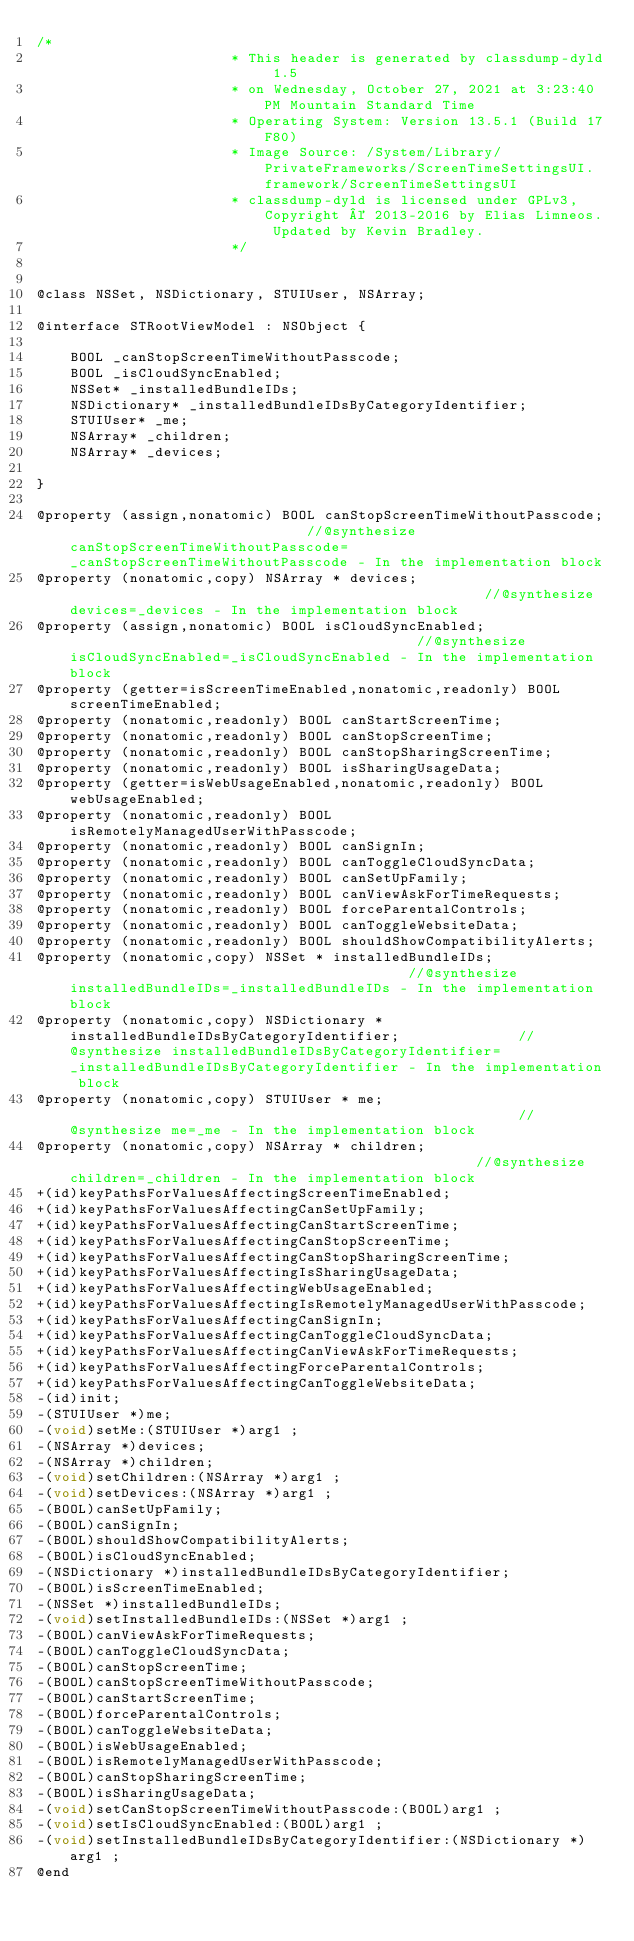<code> <loc_0><loc_0><loc_500><loc_500><_C_>/*
                       * This header is generated by classdump-dyld 1.5
                       * on Wednesday, October 27, 2021 at 3:23:40 PM Mountain Standard Time
                       * Operating System: Version 13.5.1 (Build 17F80)
                       * Image Source: /System/Library/PrivateFrameworks/ScreenTimeSettingsUI.framework/ScreenTimeSettingsUI
                       * classdump-dyld is licensed under GPLv3, Copyright © 2013-2016 by Elias Limneos. Updated by Kevin Bradley.
                       */


@class NSSet, NSDictionary, STUIUser, NSArray;

@interface STRootViewModel : NSObject {

	BOOL _canStopScreenTimeWithoutPasscode;
	BOOL _isCloudSyncEnabled;
	NSSet* _installedBundleIDs;
	NSDictionary* _installedBundleIDsByCategoryIdentifier;
	STUIUser* _me;
	NSArray* _children;
	NSArray* _devices;

}

@property (assign,nonatomic) BOOL canStopScreenTimeWithoutPasscode;                            //@synthesize canStopScreenTimeWithoutPasscode=_canStopScreenTimeWithoutPasscode - In the implementation block
@property (nonatomic,copy) NSArray * devices;                                                  //@synthesize devices=_devices - In the implementation block
@property (assign,nonatomic) BOOL isCloudSyncEnabled;                                          //@synthesize isCloudSyncEnabled=_isCloudSyncEnabled - In the implementation block
@property (getter=isScreenTimeEnabled,nonatomic,readonly) BOOL screenTimeEnabled; 
@property (nonatomic,readonly) BOOL canStartScreenTime; 
@property (nonatomic,readonly) BOOL canStopScreenTime; 
@property (nonatomic,readonly) BOOL canStopSharingScreenTime; 
@property (nonatomic,readonly) BOOL isSharingUsageData; 
@property (getter=isWebUsageEnabled,nonatomic,readonly) BOOL webUsageEnabled; 
@property (nonatomic,readonly) BOOL isRemotelyManagedUserWithPasscode; 
@property (nonatomic,readonly) BOOL canSignIn; 
@property (nonatomic,readonly) BOOL canToggleCloudSyncData; 
@property (nonatomic,readonly) BOOL canSetUpFamily; 
@property (nonatomic,readonly) BOOL canViewAskForTimeRequests; 
@property (nonatomic,readonly) BOOL forceParentalControls; 
@property (nonatomic,readonly) BOOL canToggleWebsiteData; 
@property (nonatomic,readonly) BOOL shouldShowCompatibilityAlerts; 
@property (nonatomic,copy) NSSet * installedBundleIDs;                                         //@synthesize installedBundleIDs=_installedBundleIDs - In the implementation block
@property (nonatomic,copy) NSDictionary * installedBundleIDsByCategoryIdentifier;              //@synthesize installedBundleIDsByCategoryIdentifier=_installedBundleIDsByCategoryIdentifier - In the implementation block
@property (nonatomic,copy) STUIUser * me;                                                      //@synthesize me=_me - In the implementation block
@property (nonatomic,copy) NSArray * children;                                                 //@synthesize children=_children - In the implementation block
+(id)keyPathsForValuesAffectingScreenTimeEnabled;
+(id)keyPathsForValuesAffectingCanSetUpFamily;
+(id)keyPathsForValuesAffectingCanStartScreenTime;
+(id)keyPathsForValuesAffectingCanStopScreenTime;
+(id)keyPathsForValuesAffectingCanStopSharingScreenTime;
+(id)keyPathsForValuesAffectingIsSharingUsageData;
+(id)keyPathsForValuesAffectingWebUsageEnabled;
+(id)keyPathsForValuesAffectingIsRemotelyManagedUserWithPasscode;
+(id)keyPathsForValuesAffectingCanSignIn;
+(id)keyPathsForValuesAffectingCanToggleCloudSyncData;
+(id)keyPathsForValuesAffectingCanViewAskForTimeRequests;
+(id)keyPathsForValuesAffectingForceParentalControls;
+(id)keyPathsForValuesAffectingCanToggleWebsiteData;
-(id)init;
-(STUIUser *)me;
-(void)setMe:(STUIUser *)arg1 ;
-(NSArray *)devices;
-(NSArray *)children;
-(void)setChildren:(NSArray *)arg1 ;
-(void)setDevices:(NSArray *)arg1 ;
-(BOOL)canSetUpFamily;
-(BOOL)canSignIn;
-(BOOL)shouldShowCompatibilityAlerts;
-(BOOL)isCloudSyncEnabled;
-(NSDictionary *)installedBundleIDsByCategoryIdentifier;
-(BOOL)isScreenTimeEnabled;
-(NSSet *)installedBundleIDs;
-(void)setInstalledBundleIDs:(NSSet *)arg1 ;
-(BOOL)canViewAskForTimeRequests;
-(BOOL)canToggleCloudSyncData;
-(BOOL)canStopScreenTime;
-(BOOL)canStopScreenTimeWithoutPasscode;
-(BOOL)canStartScreenTime;
-(BOOL)forceParentalControls;
-(BOOL)canToggleWebsiteData;
-(BOOL)isWebUsageEnabled;
-(BOOL)isRemotelyManagedUserWithPasscode;
-(BOOL)canStopSharingScreenTime;
-(BOOL)isSharingUsageData;
-(void)setCanStopScreenTimeWithoutPasscode:(BOOL)arg1 ;
-(void)setIsCloudSyncEnabled:(BOOL)arg1 ;
-(void)setInstalledBundleIDsByCategoryIdentifier:(NSDictionary *)arg1 ;
@end

</code> 